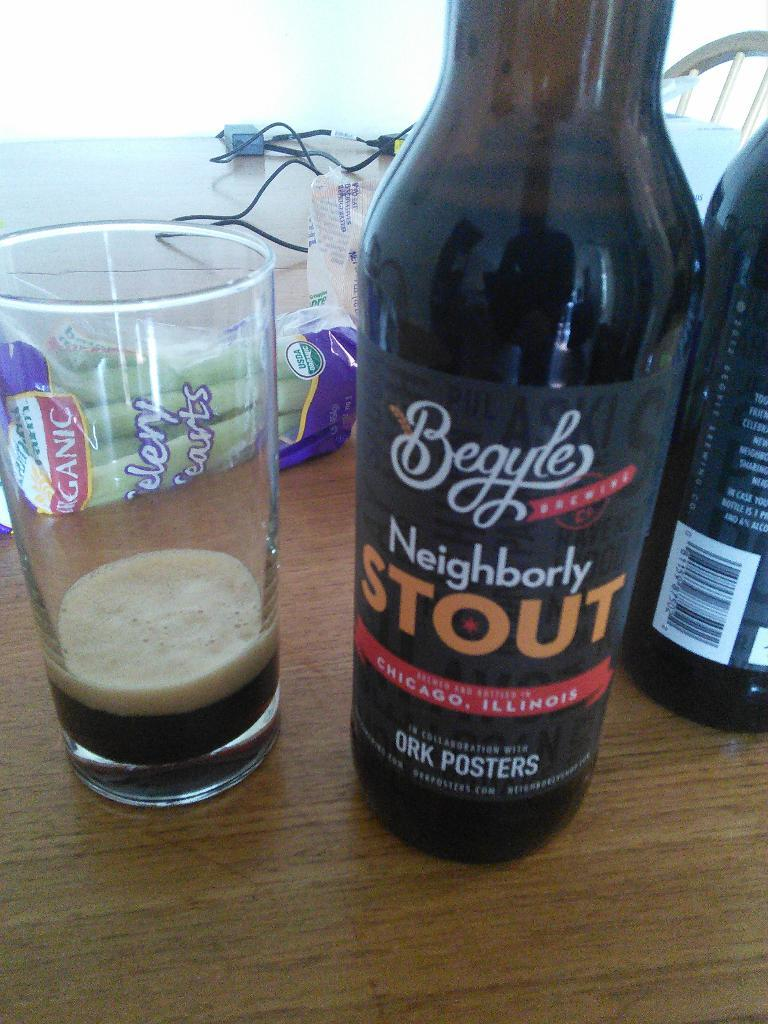<image>
Relay a brief, clear account of the picture shown. BEgyle Neighborly Stout liquor bottle poured in a cup with celery behind it on a table. 